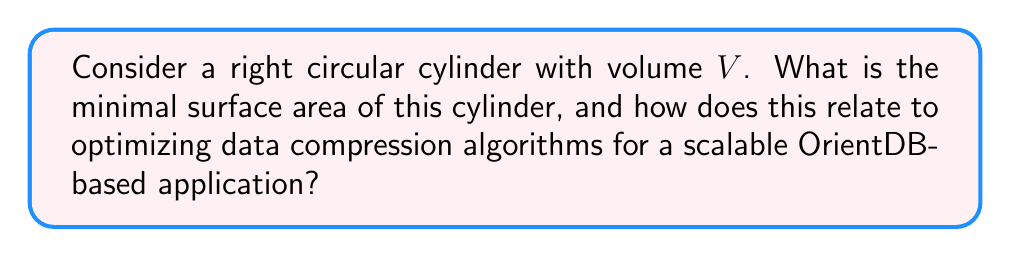Show me your answer to this math problem. Let's approach this step-by-step:

1) For a right circular cylinder with radius $r$ and height $h$, we have:
   Volume: $V = \pi r^2 h$
   Surface Area: $S = 2\pi r^2 + 2\pi rh$

2) We want to minimize $S$ for a given $V$. We can express $h$ in terms of $V$ and $r$:
   $h = \frac{V}{\pi r^2}$

3) Substituting this into the surface area equation:
   $S = 2\pi r^2 + 2\pi r(\frac{V}{\pi r^2}) = 2\pi r^2 + \frac{2V}{r}$

4) To find the minimum, we differentiate $S$ with respect to $r$ and set it to zero:
   $\frac{dS}{dr} = 4\pi r - \frac{2V}{r^2} = 0$

5) Solving this equation:
   $4\pi r^3 = 2V$
   $r^3 = \frac{V}{2\pi}$
   $r = (\frac{V}{2\pi})^{\frac{1}{3}}$

6) The corresponding height is:
   $h = \frac{V}{\pi r^2} = \frac{V}{\pi (\frac{V}{2\pi})^{\frac{2}{3}}} = 2(\frac{V}{2\pi})^{\frac{1}{3}}$

7) Note that $h = 2r$, which is a key property of the optimal cylinder.

8) The minimal surface area is:
   $S_{min} = 2\pi r^2 + 2\pi rh = 2\pi (\frac{V}{2\pi})^{\frac{2}{3}} + 4\pi (\frac{V}{2\pi})^{\frac{2}{3}} = 6(\pi V^2)^{\frac{1}{3}}$

Relation to data compression in OrientDB:
This problem relates to optimizing data storage and retrieval in OrientDB. By minimizing the surface area for a given volume, we're essentially finding the most efficient way to package data. In the context of data compression algorithms, this could translate to minimizing the "overhead" (surface area) while maximizing the actual data stored (volume). For a scalable application, this optimization could lead to more efficient use of storage space and potentially faster data access times.
Answer: $S_{min} = 6(\pi V^2)^{\frac{1}{3}}$, where $V$ is the given volume 